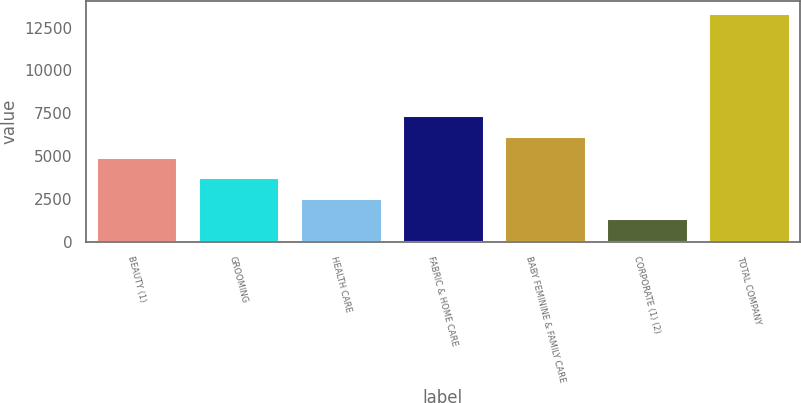Convert chart. <chart><loc_0><loc_0><loc_500><loc_500><bar_chart><fcel>BEAUTY (1)<fcel>GROOMING<fcel>HEALTH CARE<fcel>FABRIC & HOME CARE<fcel>BABY FEMININE & FAMILY CARE<fcel>CORPORATE (1) (2)<fcel>TOTAL COMPANY<nl><fcel>4976<fcel>3777<fcel>2578<fcel>7374<fcel>6175<fcel>1379<fcel>13369<nl></chart> 